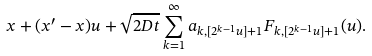<formula> <loc_0><loc_0><loc_500><loc_500>x + ( x ^ { \prime } - x ) u + \sqrt { 2 D t } \sum _ { k = 1 } ^ { \infty } a _ { k , [ 2 ^ { k - 1 } u ] + 1 } F _ { k , [ 2 ^ { k - 1 } u ] + 1 } ( u ) .</formula> 